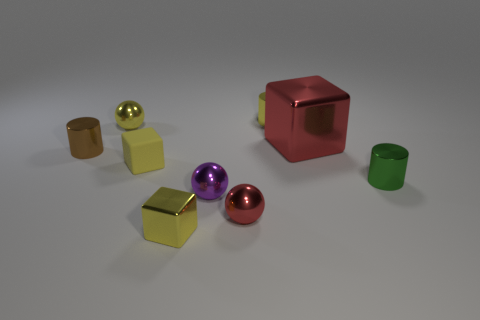Subtract all tiny yellow blocks. How many blocks are left? 1 Subtract all blocks. How many objects are left? 6 Add 3 yellow cylinders. How many yellow cylinders are left? 4 Add 5 brown cubes. How many brown cubes exist? 5 Subtract 0 green spheres. How many objects are left? 9 Subtract all big shiny cylinders. Subtract all purple objects. How many objects are left? 8 